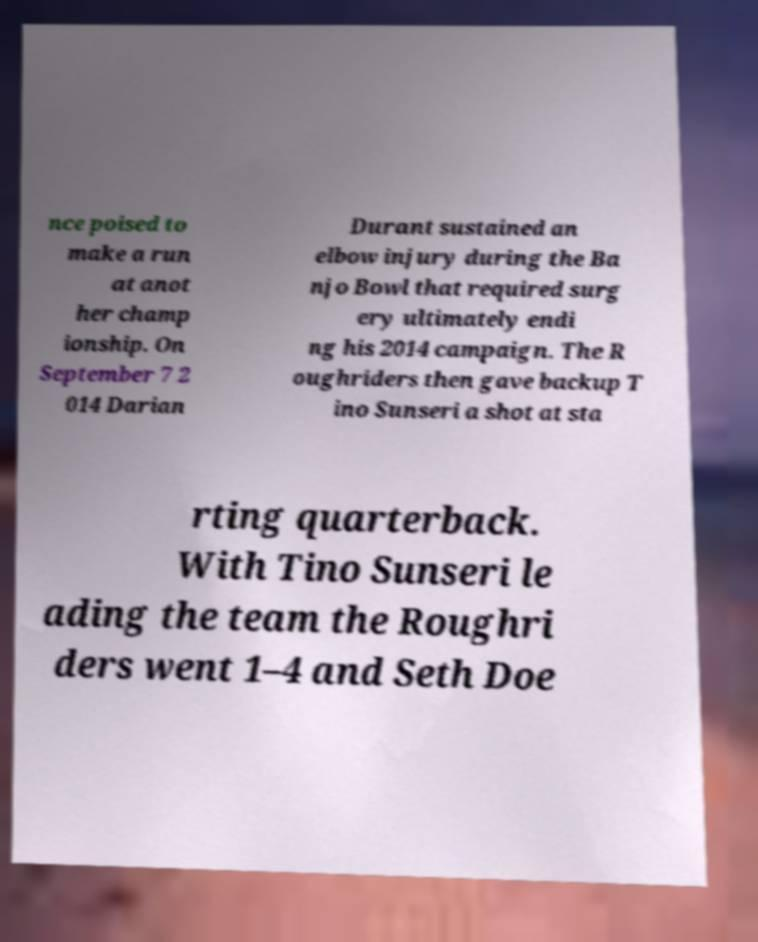Could you assist in decoding the text presented in this image and type it out clearly? nce poised to make a run at anot her champ ionship. On September 7 2 014 Darian Durant sustained an elbow injury during the Ba njo Bowl that required surg ery ultimately endi ng his 2014 campaign. The R oughriders then gave backup T ino Sunseri a shot at sta rting quarterback. With Tino Sunseri le ading the team the Roughri ders went 1–4 and Seth Doe 